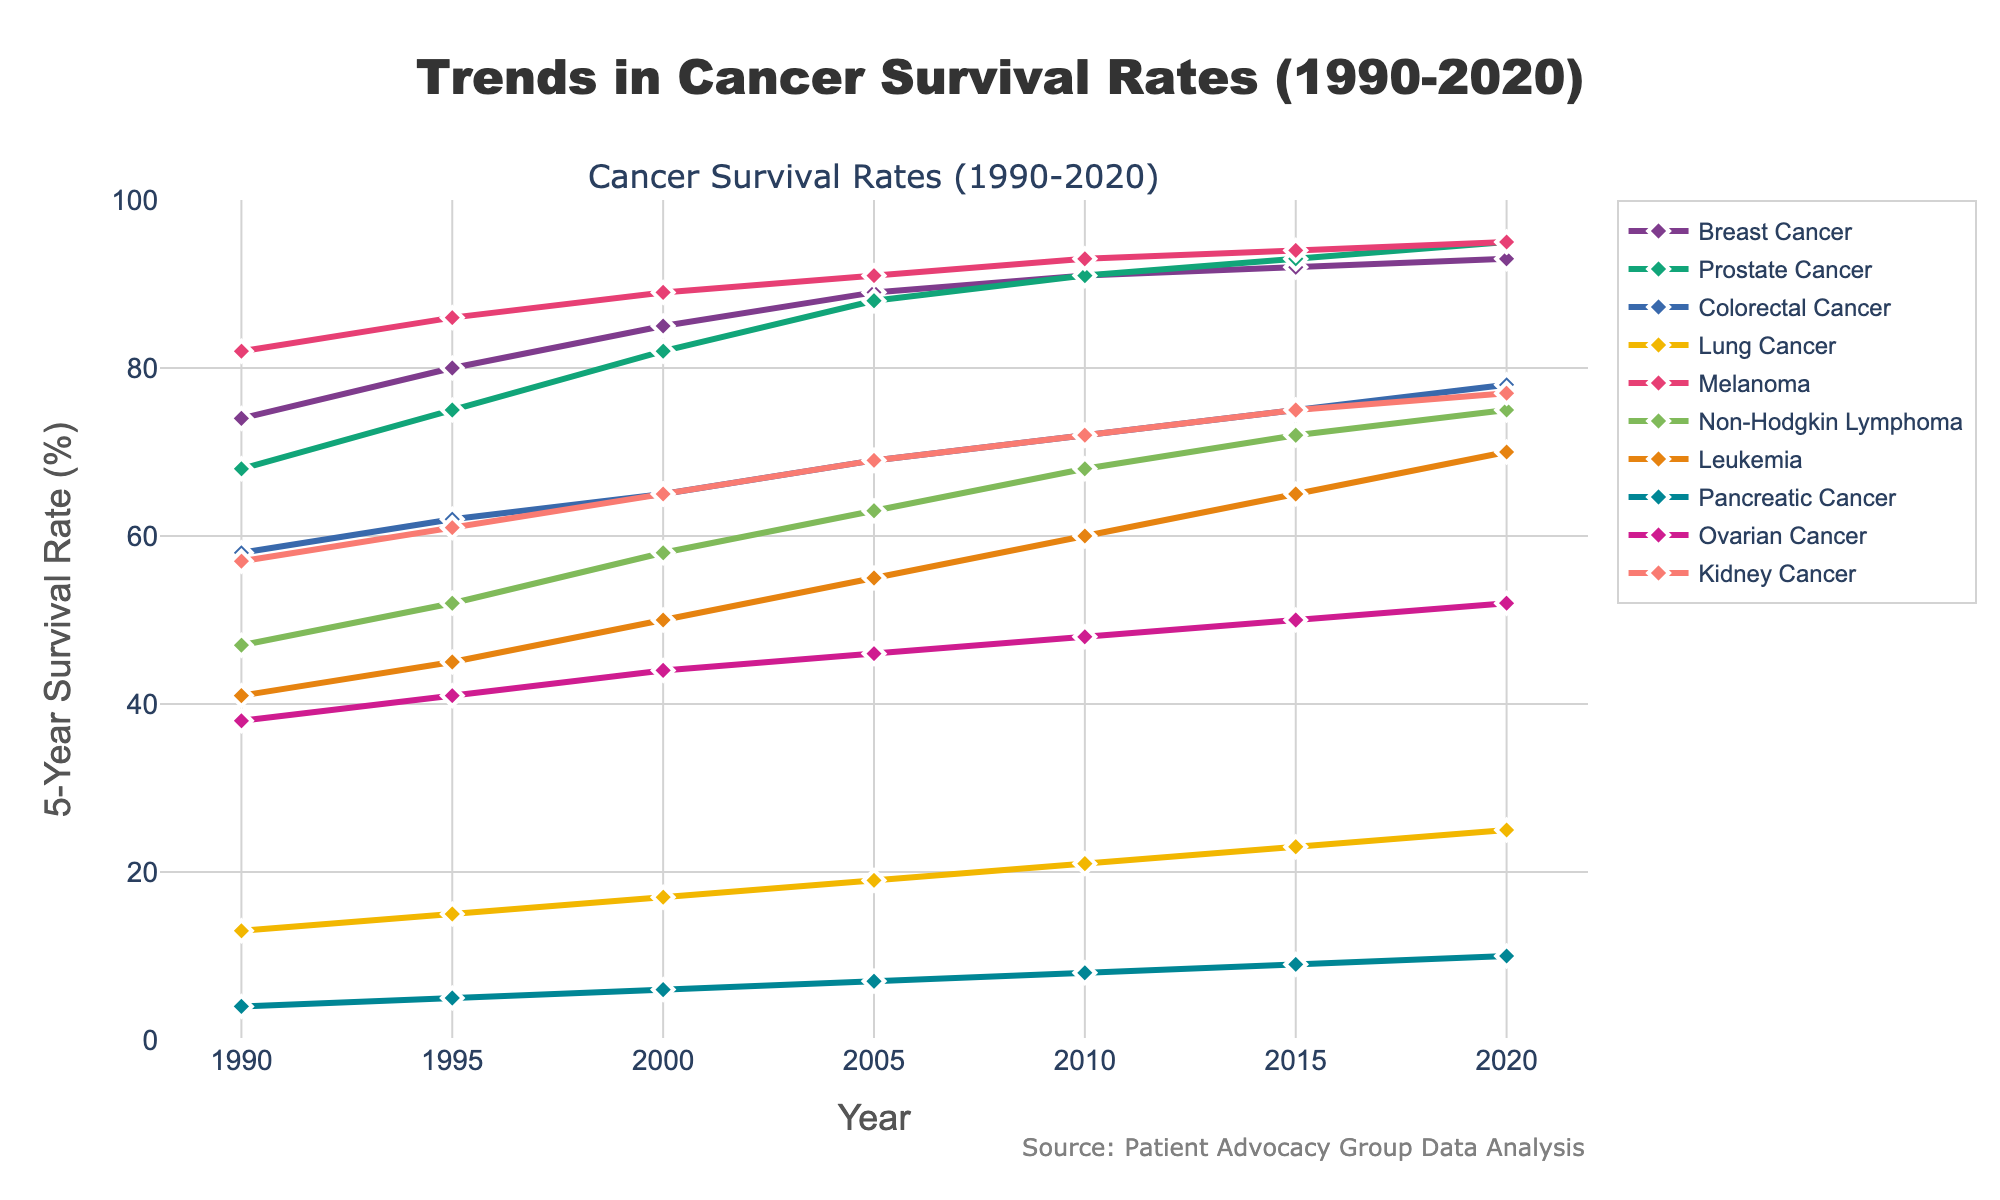What is the difference in survival rates between Prostate Cancer and Leukemia in 2020? In 2020, the survival rate for Prostate Cancer is 95% and for Leukemia is 70%. The difference is calculated as 95 - 70.
Answer: 25% Which cancer type had the lowest survival rate in 1990? By looking at the data points in 1990, Pancreatic Cancer had the lowest survival rate at 4%.
Answer: Pancreatic Cancer Has the survival rate for Lung Cancer shown any consistent increase over the years? Observing the survival rates for Lung Cancer from 1990 to 2020, the rates are 13, 15, 17, 19, 21, 23, and 25. Each successive year shows an increase.
Answer: Yes Which cancer types had a survival rate of 95% in 2020? In 2020, Prostate Cancer and Melanoma both had survival rates of 95%.
Answer: Prostate Cancer, Melanoma What is the average survival rate for Colorectal Cancer between 1990 and 2020? The survival rates for Colorectal Cancer across the years are 58, 62, 65, 69, 72, 75, and 78. Summing these gives 479. The average rate is 479 / 7.
Answer: 68.43% How much did the survival rate for Breast Cancer increase from 1990 to 2020? The survival rate for Breast Cancer in 1990 was 74%, and in 2020, it was 93%. The increase is calculated as 93 - 74.
Answer: 19% Which cancer type had the largest increase in survival rate from 1990 to 2020? By calculating the difference for each cancer type between 1990 and 2020, Prostate Cancer had the largest increase from 68% to 95%, which is 27%.
Answer: Prostate Cancer Is the survival rate for Non-Hodgkin Lymphoma higher than Kid Cancer in 2020? In 2020, the survival rate for Non-Hodgkin Lymphoma is 75%, whereas for Kidney Cancer it is 77%.
Answer: No 